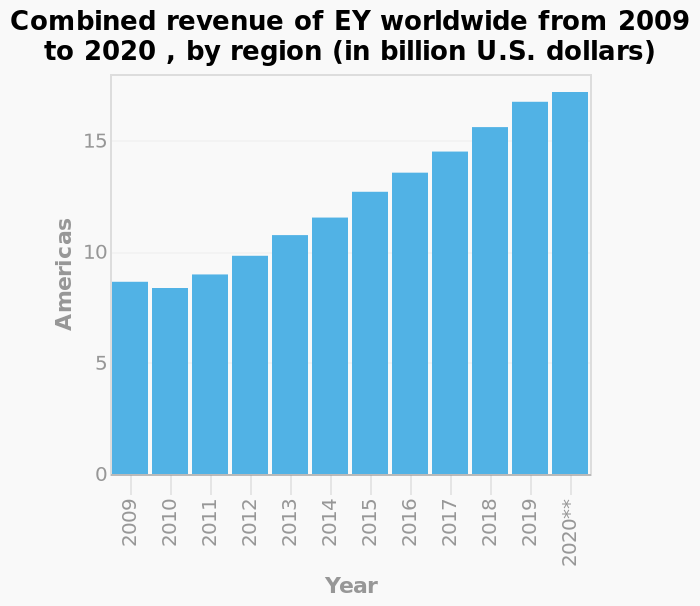<image>
What was the trend in EY's revenue between 2009 and 2020? The combined revenue of EY increased overall between 2009 and 2020. What was the only year in which EY's revenue decreased? The only year in which EY's revenue decreased was in 2010. 